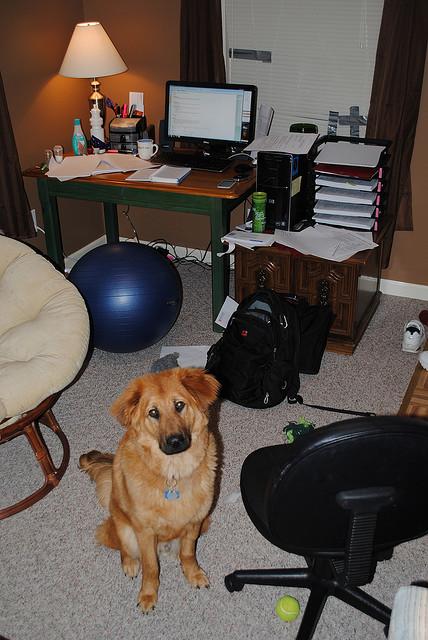What color is the animal?
Short answer required. Brown. How many balls do you see on the ground?
Short answer required. 2. What is the dog looking at the camera?
Write a very short answer. Yes. Is the dog cold?
Keep it brief. No. Where is the dog?
Quick response, please. Office. Does the dog look like it wants to play with the ball?
Answer briefly. No. What is the name of this dog?
Keep it brief. Brownie. 